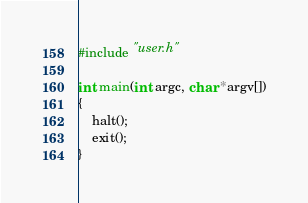Convert code to text. <code><loc_0><loc_0><loc_500><loc_500><_C_>#include "user.h"

int main(int argc, char *argv[])
{
	halt();
	exit();
}
</code> 